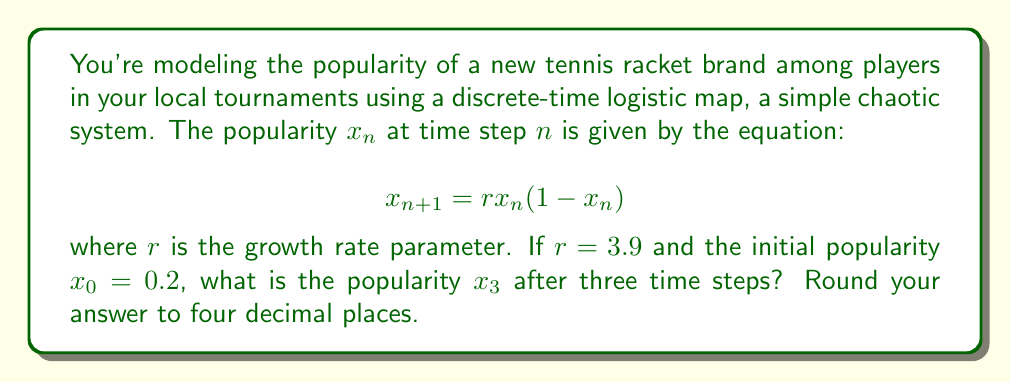Give your solution to this math problem. To solve this problem, we need to iterate the logistic map equation three times:

Step 1: Calculate $x_1$
$$x_1 = rx_0(1-x_0) = 3.9 \cdot 0.2 \cdot (1-0.2) = 3.9 \cdot 0.2 \cdot 0.8 = 0.624$$

Step 2: Calculate $x_2$
$$x_2 = rx_1(1-x_1) = 3.9 \cdot 0.624 \cdot (1-0.624) = 3.9 \cdot 0.624 \cdot 0.376 = 0.9165696$$

Step 3: Calculate $x_3$
$$x_3 = rx_2(1-x_2) = 3.9 \cdot 0.9165696 \cdot (1-0.9165696) = 3.9 \cdot 0.9165696 \cdot 0.0834304 = 0.2976532$$

Step 4: Round to four decimal places
$0.2976532$ rounded to four decimal places is $0.2977$.

This result shows how the popularity of the tennis racket brand evolves over three time steps in this chaotic system, demonstrating the sensitivity to initial conditions characteristic of chaos theory.
Answer: $0.2977$ 